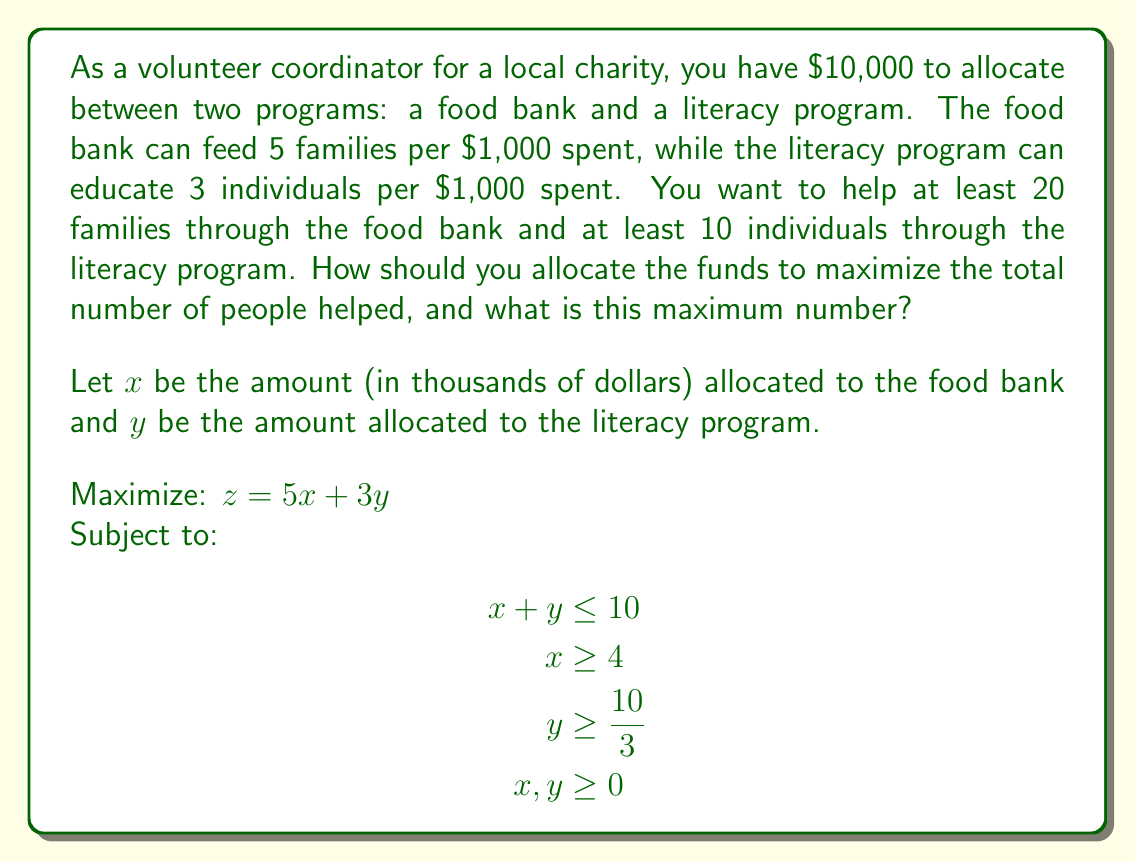Help me with this question. To solve this linear programming problem, we'll follow these steps:

1) First, let's graph the constraints:
   $x + y = 10$ (budget constraint)
   $x = 4$ (minimum for food bank)
   $y = \frac{10}{3}$ (minimum for literacy program)

2) The feasible region is the area that satisfies all constraints. It's the triangle formed by the points (4, 6), (6.67, 3.33), and (4, 3.33).

3) The objective function $z = 5x + 3y$ represents a family of parallel lines. The optimal solution will be at one of the corner points of the feasible region.

4) Let's evaluate $z$ at each corner point:
   At (4, 6): $z = 5(4) + 3(6) = 38$
   At (6.67, 3.33): $z = 5(6.67) + 3(3.33) = 43.33$
   At (4, 3.33): $z = 5(4) + 3(3.33) = 30$

5) The maximum value of $z$ occurs at the point (6.67, 3.33).

6) This means we should allocate:
   $6,670 to the food bank (feeding 33.35 families)
   $3,330 to the literacy program (educating 9.99 individuals)

7) The total number of people helped is 43.34, which rounds down to 43 as we can't help fractional people.
Answer: Allocate $6,670 to the food bank and $3,330 to the literacy program, helping 43 people in total. 